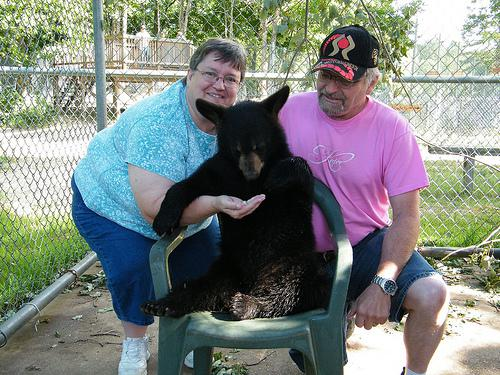Question: what is in the picture?
Choices:
A. A zebra.
B. A bear.
C. A raccoon.
D. A beaver.
Answer with the letter. Answer: B Question: what is the woman doing in the picture?
Choices:
A. Feeding the bear.
B. Petting the goat.
C. Playing with the sheep.
D. Watching the cubs.
Answer with the letter. Answer: A 